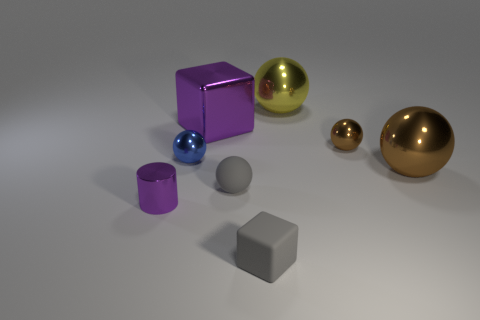Subtract all blue balls. How many balls are left? 4 Subtract all large brown metal balls. How many balls are left? 4 Subtract all green balls. Subtract all gray cubes. How many balls are left? 5 Add 1 big yellow metal cylinders. How many objects exist? 9 Subtract all blocks. How many objects are left? 6 Subtract 0 red cylinders. How many objects are left? 8 Subtract all large cubes. Subtract all large metallic cubes. How many objects are left? 6 Add 8 purple cylinders. How many purple cylinders are left? 9 Add 6 big cyan metallic blocks. How many big cyan metallic blocks exist? 6 